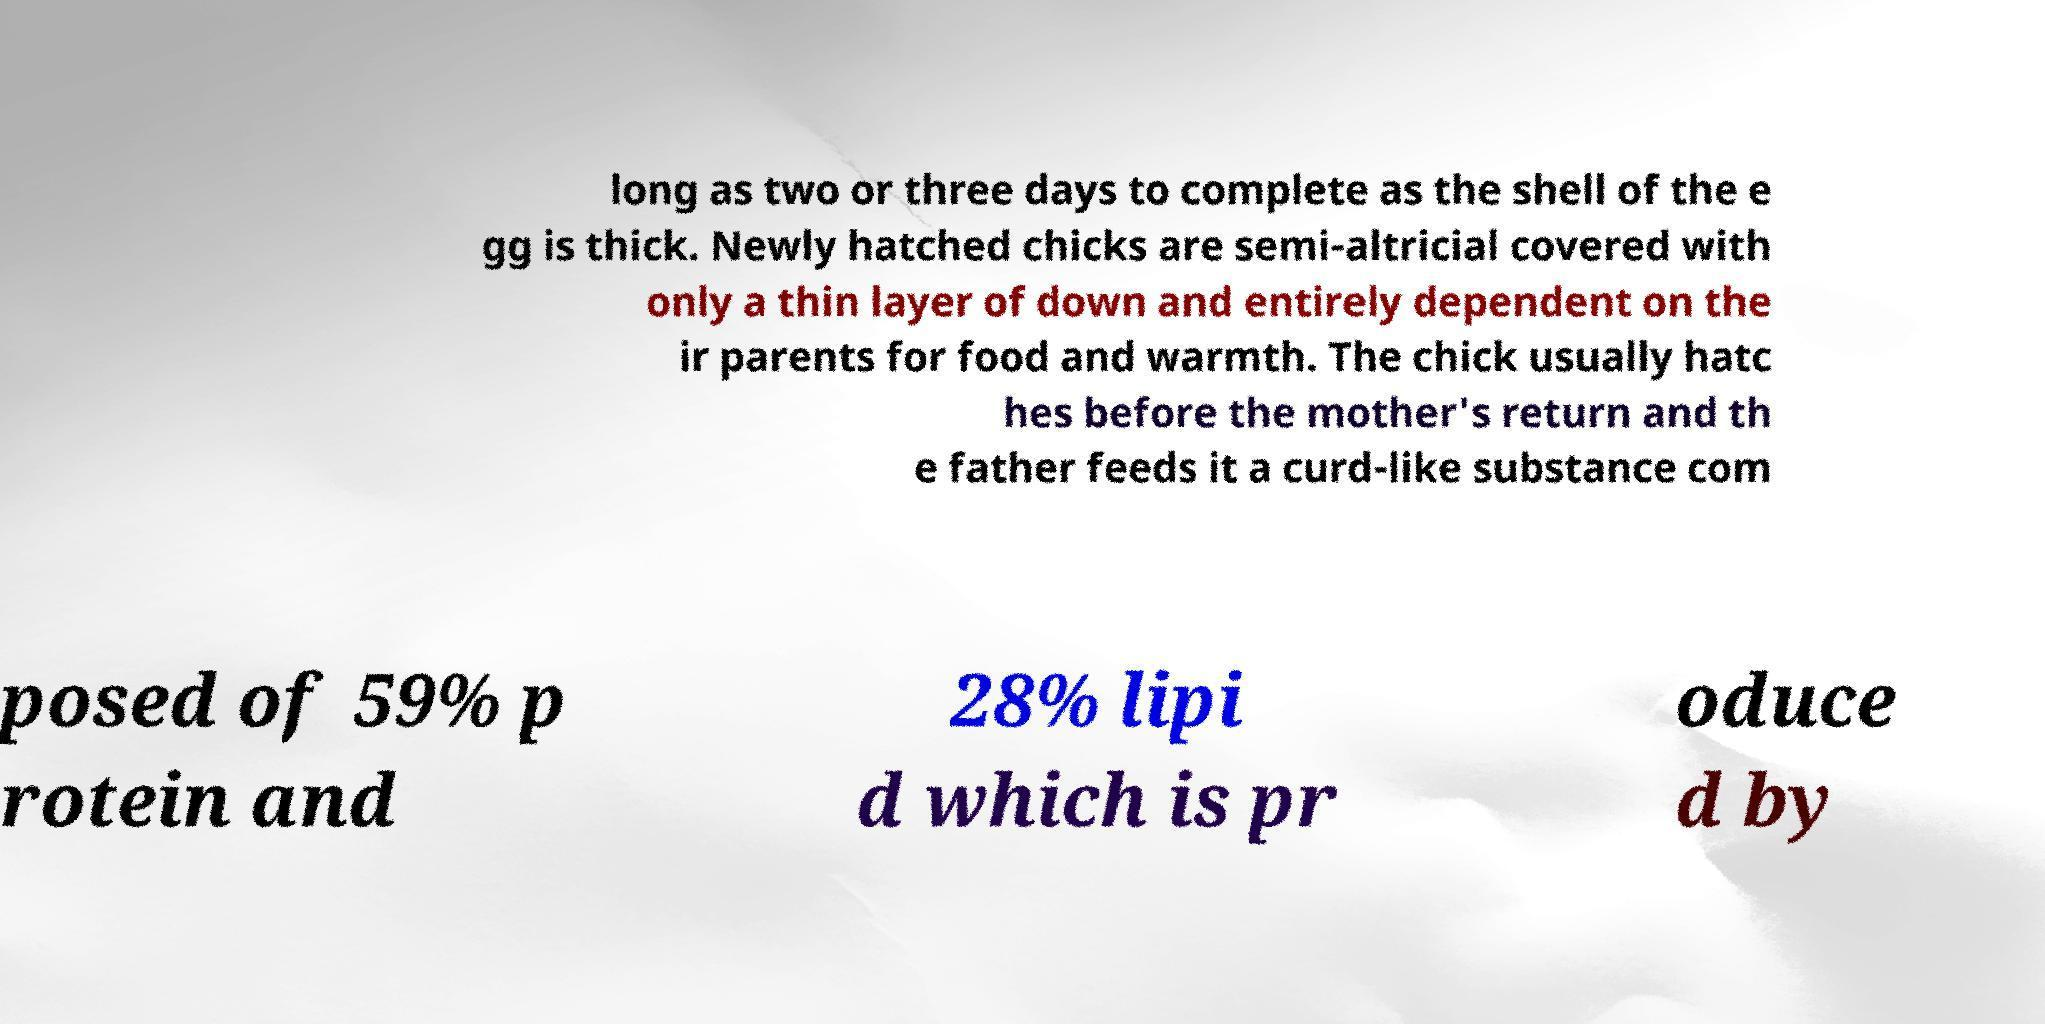Can you accurately transcribe the text from the provided image for me? long as two or three days to complete as the shell of the e gg is thick. Newly hatched chicks are semi-altricial covered with only a thin layer of down and entirely dependent on the ir parents for food and warmth. The chick usually hatc hes before the mother's return and th e father feeds it a curd-like substance com posed of 59% p rotein and 28% lipi d which is pr oduce d by 